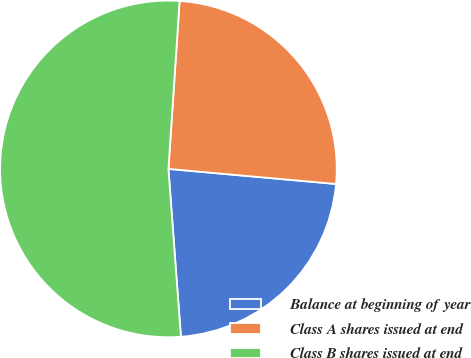<chart> <loc_0><loc_0><loc_500><loc_500><pie_chart><fcel>Balance at beginning of year<fcel>Class A shares issued at end<fcel>Class B shares issued at end<nl><fcel>22.39%<fcel>25.37%<fcel>52.24%<nl></chart> 